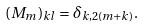<formula> <loc_0><loc_0><loc_500><loc_500>( M _ { m } ) _ { k l } = \delta _ { k , 2 ( m + k ) } .</formula> 